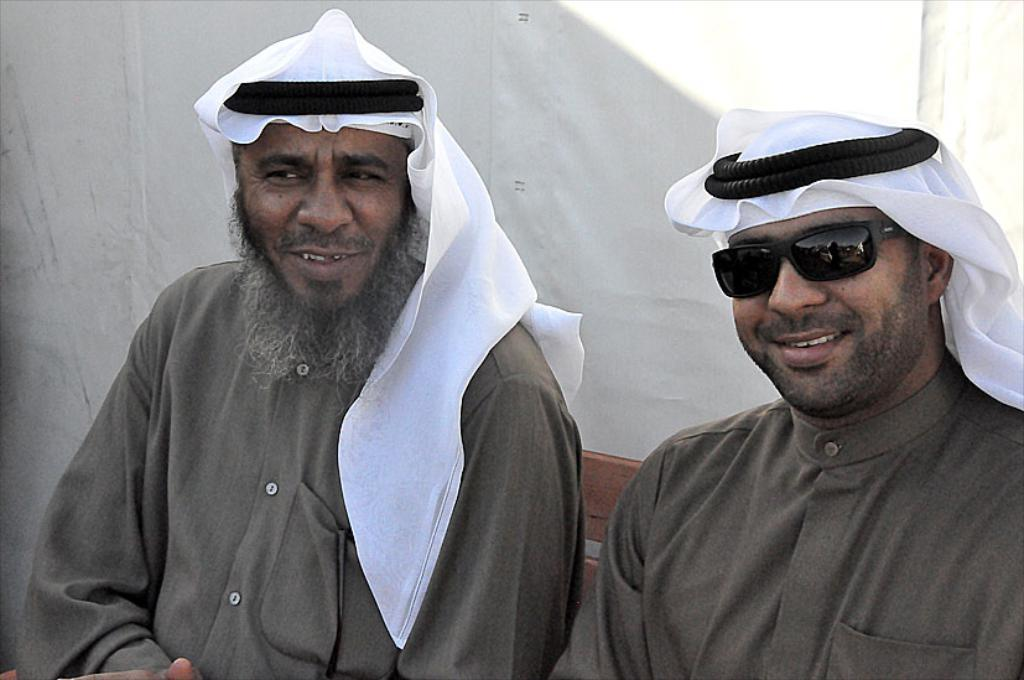How many people are in the image? There are two men in the image. What are the men doing in the image? The men are sitting. What is the facial expression of the men in the image? The men are smiling. What type of clothing are the men wearing in the image? The men are wearing Arabic head turbans and kurtas. What can be seen in the background of the image? There is a white cloth in the background of the image. What type of disease can be seen affecting the trees in the image? There are no trees present in the image, so it is not possible to determine if any disease is affecting them. 